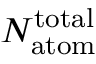Convert formula to latex. <formula><loc_0><loc_0><loc_500><loc_500>N _ { a t o m } ^ { t o t a l }</formula> 